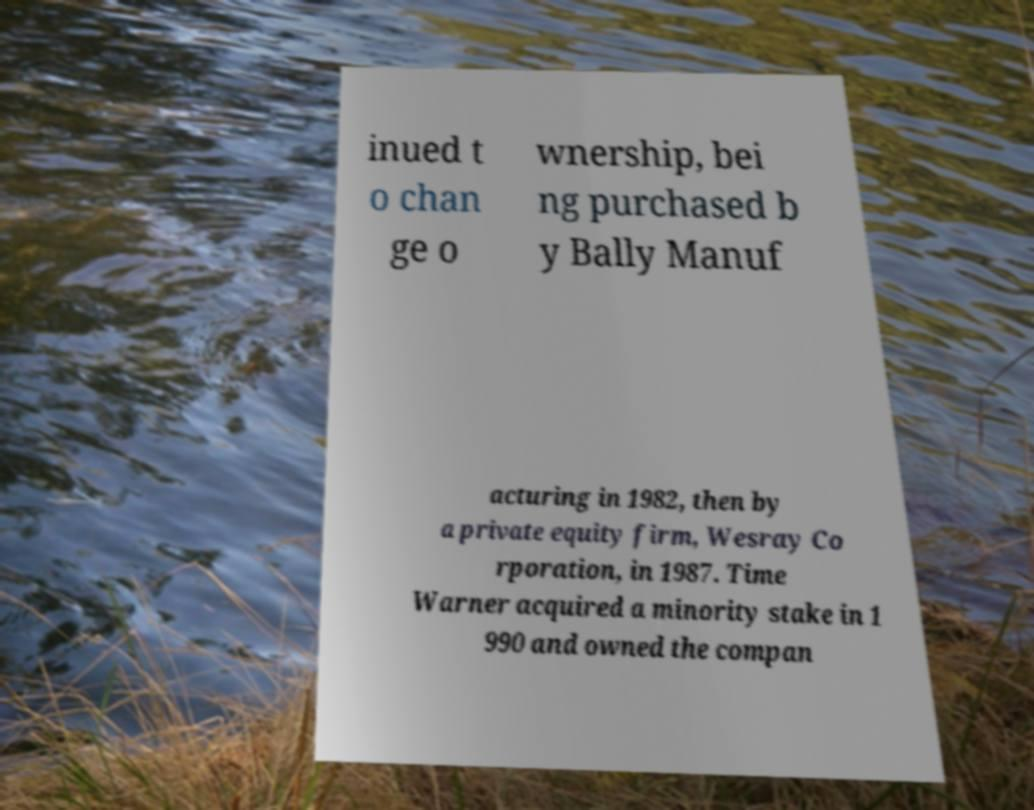Can you read and provide the text displayed in the image?This photo seems to have some interesting text. Can you extract and type it out for me? inued t o chan ge o wnership, bei ng purchased b y Bally Manuf acturing in 1982, then by a private equity firm, Wesray Co rporation, in 1987. Time Warner acquired a minority stake in 1 990 and owned the compan 